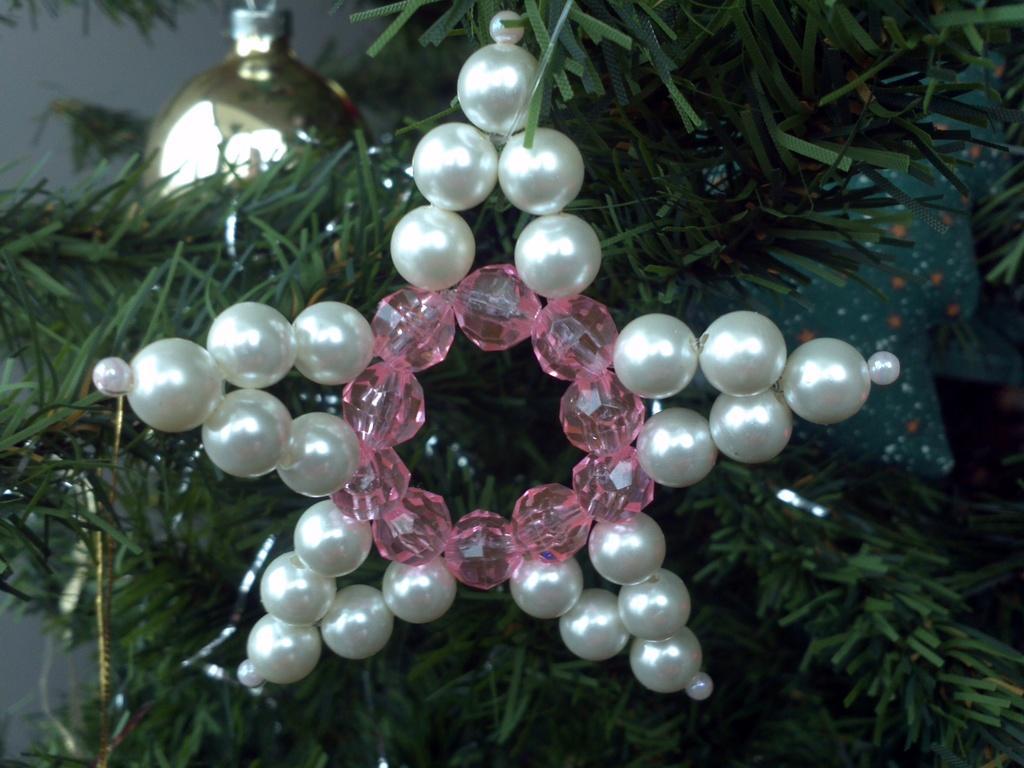Please provide a concise description of this image. Here it seems to be a Christmas tree. It is decorated with some pearls. 